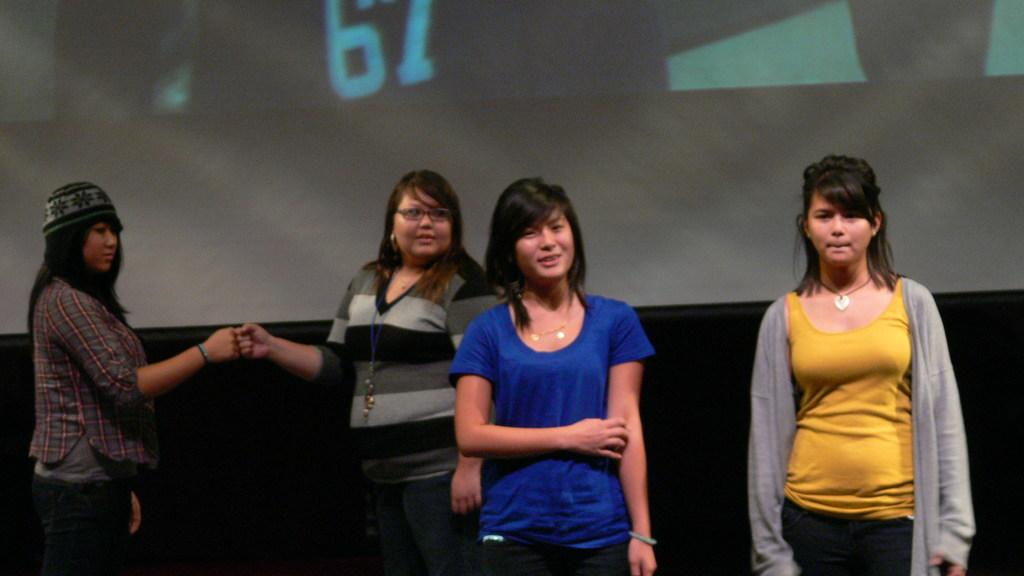How many people are present in the image? There are four people in the image. Where are the people located? The people are on a desk. What can be seen in the background of the image? There is an LCD screen in the background of the image. What type of pollution is visible in the image? There is no visible pollution in the image. Are the people in the image planning a trip together? The image does not provide any information about the people's plans or activities, so it cannot be determined if they are planning a trip together. 